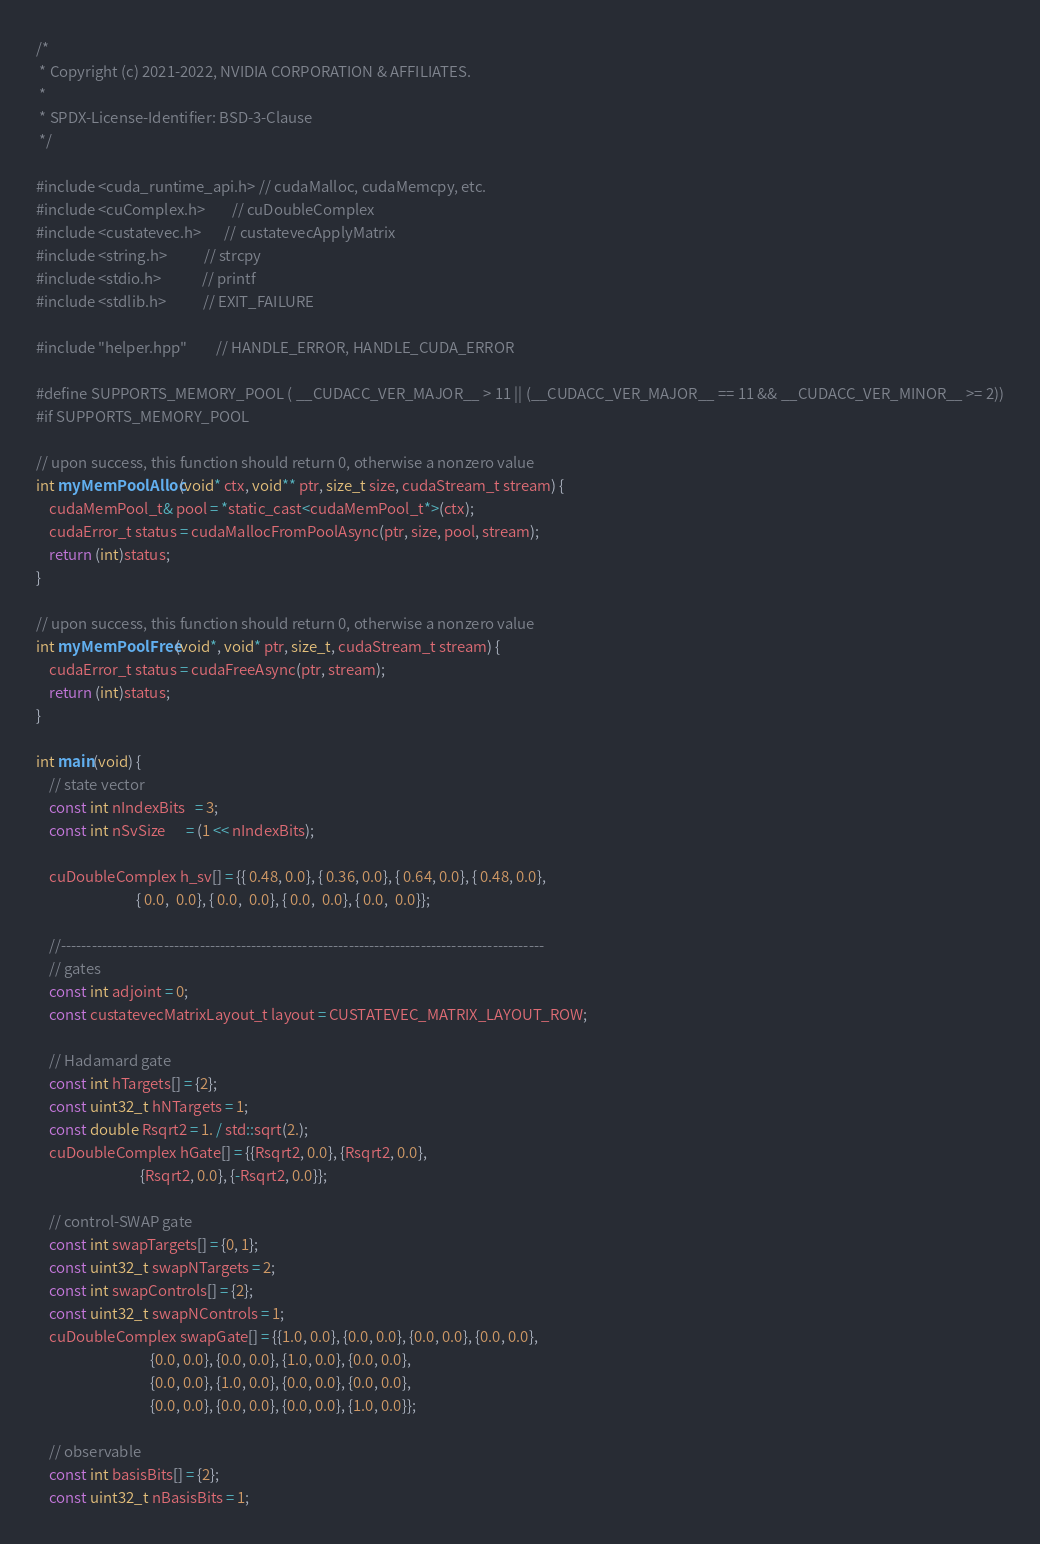Convert code to text. <code><loc_0><loc_0><loc_500><loc_500><_Cuda_>/*
 * Copyright (c) 2021-2022, NVIDIA CORPORATION & AFFILIATES.
 *
 * SPDX-License-Identifier: BSD-3-Clause
 */

#include <cuda_runtime_api.h> // cudaMalloc, cudaMemcpy, etc.
#include <cuComplex.h>        // cuDoubleComplex
#include <custatevec.h>       // custatevecApplyMatrix
#include <string.h>           // strcpy
#include <stdio.h>            // printf
#include <stdlib.h>           // EXIT_FAILURE

#include "helper.hpp"         // HANDLE_ERROR, HANDLE_CUDA_ERROR

#define SUPPORTS_MEMORY_POOL ( __CUDACC_VER_MAJOR__ > 11 || (__CUDACC_VER_MAJOR__ == 11 && __CUDACC_VER_MINOR__ >= 2))
#if SUPPORTS_MEMORY_POOL

// upon success, this function should return 0, otherwise a nonzero value
int myMemPoolAlloc(void* ctx, void** ptr, size_t size, cudaStream_t stream) {
    cudaMemPool_t& pool = *static_cast<cudaMemPool_t*>(ctx);
    cudaError_t status = cudaMallocFromPoolAsync(ptr, size, pool, stream);
    return (int)status;
}

// upon success, this function should return 0, otherwise a nonzero value
int myMemPoolFree(void*, void* ptr, size_t, cudaStream_t stream) {
    cudaError_t status = cudaFreeAsync(ptr, stream);
    return (int)status;
}

int main(void) {
    // state vector
    const int nIndexBits   = 3;
    const int nSvSize      = (1 << nIndexBits);

    cuDoubleComplex h_sv[] = {{ 0.48, 0.0}, { 0.36, 0.0}, { 0.64, 0.0}, { 0.48, 0.0}, 
                              { 0.0,  0.0}, { 0.0,  0.0}, { 0.0,  0.0}, { 0.0,  0.0}};

    //----------------------------------------------------------------------------------------------
    // gates
    const int adjoint = 0;
    const custatevecMatrixLayout_t layout = CUSTATEVEC_MATRIX_LAYOUT_ROW;

    // Hadamard gate
    const int hTargets[] = {2};
    const uint32_t hNTargets = 1;
    const double Rsqrt2 = 1. / std::sqrt(2.);
    cuDoubleComplex hGate[] = {{Rsqrt2, 0.0}, {Rsqrt2, 0.0},
                               {Rsqrt2, 0.0}, {-Rsqrt2, 0.0}};

    // control-SWAP gate
    const int swapTargets[] = {0, 1};
    const uint32_t swapNTargets = 2;
    const int swapControls[] = {2};
    const uint32_t swapNControls = 1;
    cuDoubleComplex swapGate[] = {{1.0, 0.0}, {0.0, 0.0}, {0.0, 0.0}, {0.0, 0.0},
                                  {0.0, 0.0}, {0.0, 0.0}, {1.0, 0.0}, {0.0, 0.0},
                                  {0.0, 0.0}, {1.0, 0.0}, {0.0, 0.0}, {0.0, 0.0},
                                  {0.0, 0.0}, {0.0, 0.0}, {0.0, 0.0}, {1.0, 0.0}};

    // observable
    const int basisBits[] = {2};
    const uint32_t nBasisBits = 1;</code> 